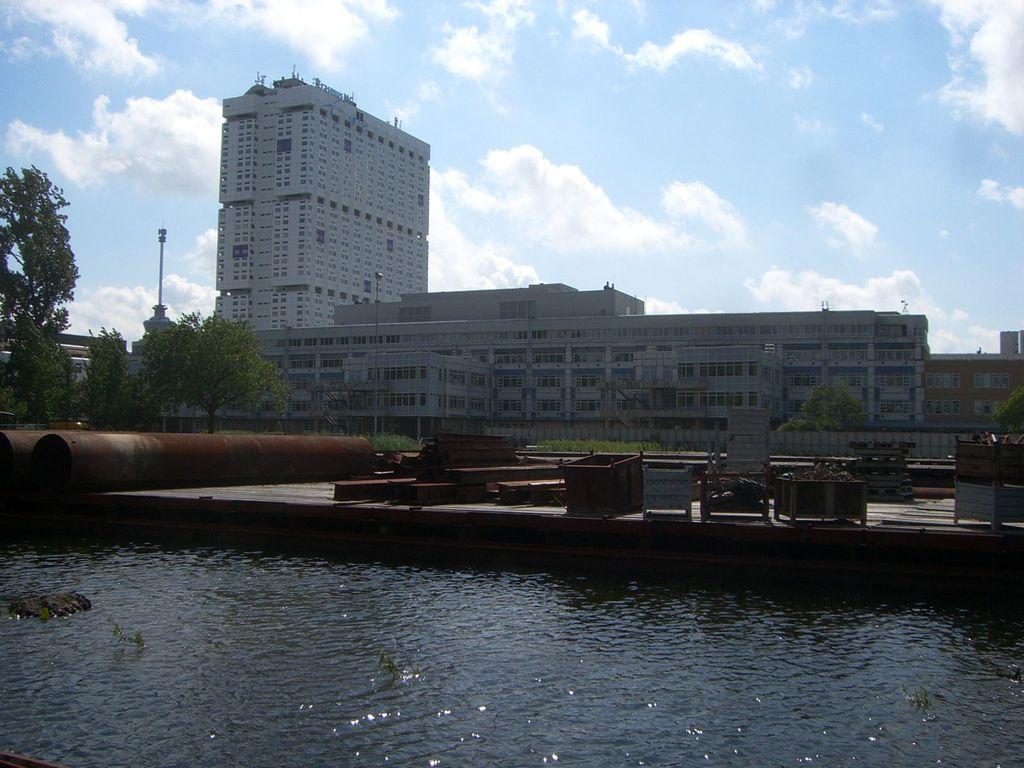Describe this image in one or two sentences. At the bottom, we see water and this water might be in the canal. Beside that, we see iron rods and boxes. On the left side, we see the iron rods and trees. There are trees, buildings and poles in the background. At the top, we see the sky and the clouds. 